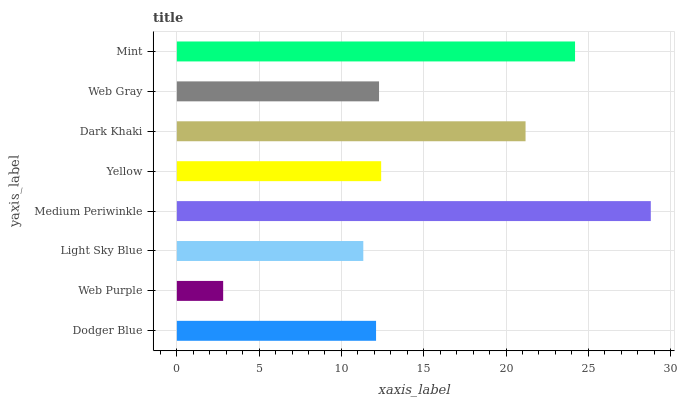Is Web Purple the minimum?
Answer yes or no. Yes. Is Medium Periwinkle the maximum?
Answer yes or no. Yes. Is Light Sky Blue the minimum?
Answer yes or no. No. Is Light Sky Blue the maximum?
Answer yes or no. No. Is Light Sky Blue greater than Web Purple?
Answer yes or no. Yes. Is Web Purple less than Light Sky Blue?
Answer yes or no. Yes. Is Web Purple greater than Light Sky Blue?
Answer yes or no. No. Is Light Sky Blue less than Web Purple?
Answer yes or no. No. Is Yellow the high median?
Answer yes or no. Yes. Is Web Gray the low median?
Answer yes or no. Yes. Is Dark Khaki the high median?
Answer yes or no. No. Is Dodger Blue the low median?
Answer yes or no. No. 